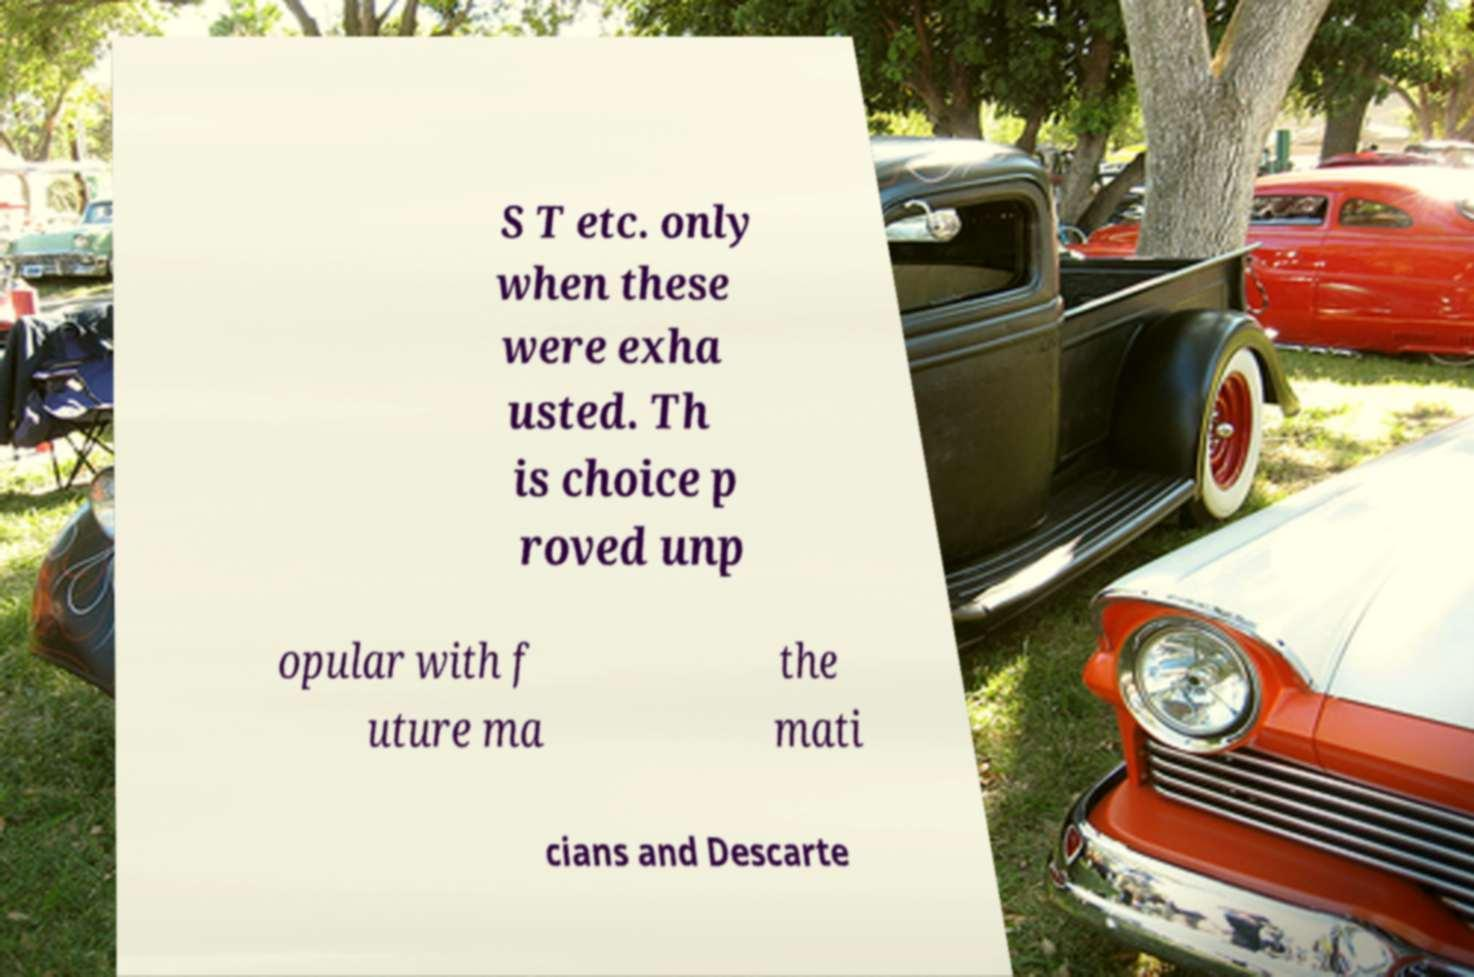Please read and relay the text visible in this image. What does it say? S T etc. only when these were exha usted. Th is choice p roved unp opular with f uture ma the mati cians and Descarte 